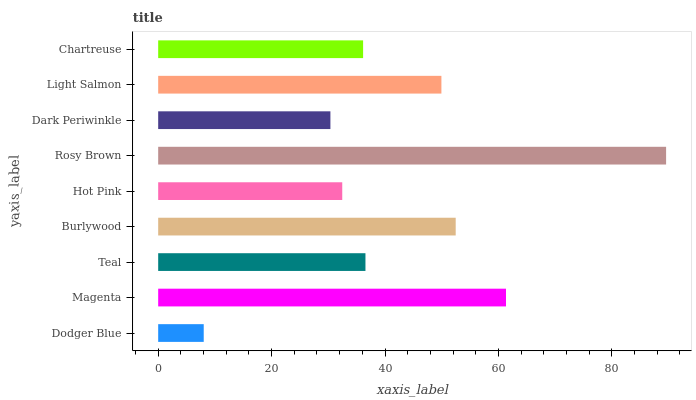Is Dodger Blue the minimum?
Answer yes or no. Yes. Is Rosy Brown the maximum?
Answer yes or no. Yes. Is Magenta the minimum?
Answer yes or no. No. Is Magenta the maximum?
Answer yes or no. No. Is Magenta greater than Dodger Blue?
Answer yes or no. Yes. Is Dodger Blue less than Magenta?
Answer yes or no. Yes. Is Dodger Blue greater than Magenta?
Answer yes or no. No. Is Magenta less than Dodger Blue?
Answer yes or no. No. Is Teal the high median?
Answer yes or no. Yes. Is Teal the low median?
Answer yes or no. Yes. Is Dodger Blue the high median?
Answer yes or no. No. Is Rosy Brown the low median?
Answer yes or no. No. 